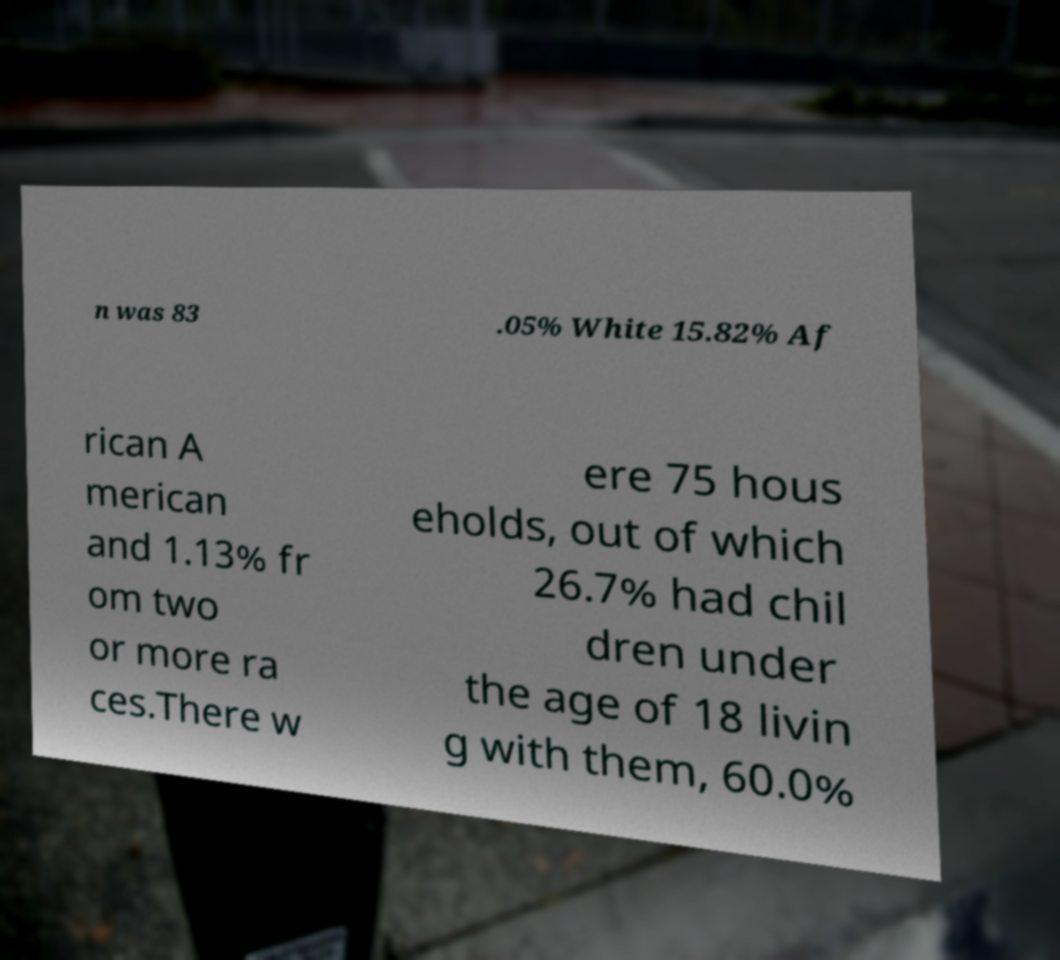Please identify and transcribe the text found in this image. n was 83 .05% White 15.82% Af rican A merican and 1.13% fr om two or more ra ces.There w ere 75 hous eholds, out of which 26.7% had chil dren under the age of 18 livin g with them, 60.0% 